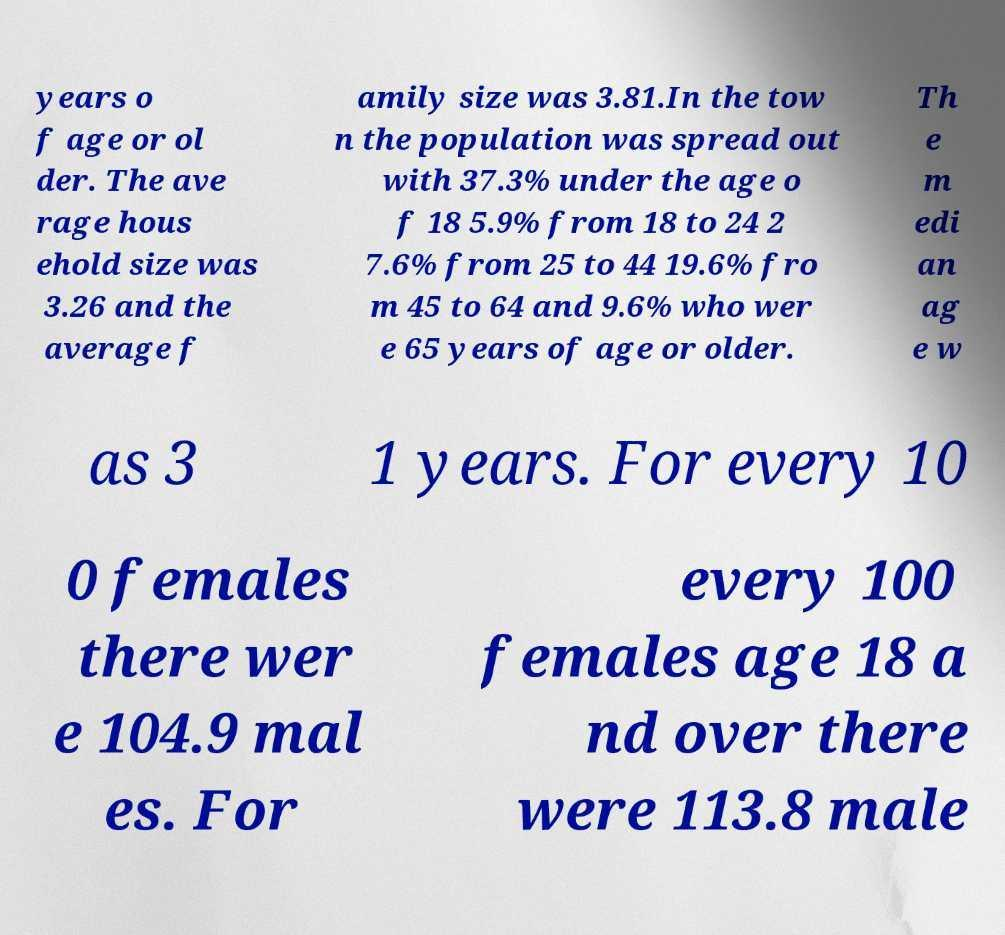I need the written content from this picture converted into text. Can you do that? years o f age or ol der. The ave rage hous ehold size was 3.26 and the average f amily size was 3.81.In the tow n the population was spread out with 37.3% under the age o f 18 5.9% from 18 to 24 2 7.6% from 25 to 44 19.6% fro m 45 to 64 and 9.6% who wer e 65 years of age or older. Th e m edi an ag e w as 3 1 years. For every 10 0 females there wer e 104.9 mal es. For every 100 females age 18 a nd over there were 113.8 male 